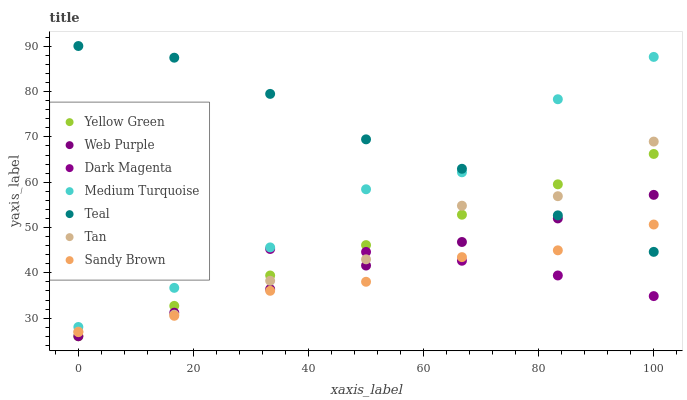Does Sandy Brown have the minimum area under the curve?
Answer yes or no. Yes. Does Teal have the maximum area under the curve?
Answer yes or no. Yes. Does Yellow Green have the minimum area under the curve?
Answer yes or no. No. Does Yellow Green have the maximum area under the curve?
Answer yes or no. No. Is Web Purple the smoothest?
Answer yes or no. Yes. Is Tan the roughest?
Answer yes or no. Yes. Is Yellow Green the smoothest?
Answer yes or no. No. Is Yellow Green the roughest?
Answer yes or no. No. Does Yellow Green have the lowest value?
Answer yes or no. Yes. Does Teal have the lowest value?
Answer yes or no. No. Does Teal have the highest value?
Answer yes or no. Yes. Does Yellow Green have the highest value?
Answer yes or no. No. Is Web Purple less than Medium Turquoise?
Answer yes or no. Yes. Is Tan greater than Sandy Brown?
Answer yes or no. Yes. Does Tan intersect Dark Magenta?
Answer yes or no. Yes. Is Tan less than Dark Magenta?
Answer yes or no. No. Is Tan greater than Dark Magenta?
Answer yes or no. No. Does Web Purple intersect Medium Turquoise?
Answer yes or no. No. 